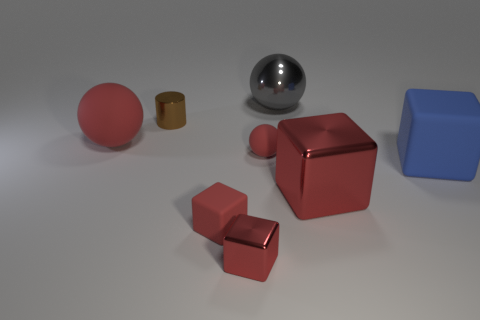How many red spheres must be subtracted to get 1 red spheres? 1 Add 1 big matte spheres. How many objects exist? 9 Subtract all red spheres. How many spheres are left? 1 Subtract all brown cylinders. How many red cubes are left? 3 Subtract all blue cubes. How many cubes are left? 3 Subtract 2 cubes. How many cubes are left? 2 Subtract all cylinders. How many objects are left? 7 Subtract all large rubber cubes. Subtract all tiny brown objects. How many objects are left? 6 Add 3 brown metal things. How many brown metal things are left? 4 Add 5 small red metallic things. How many small red metallic things exist? 6 